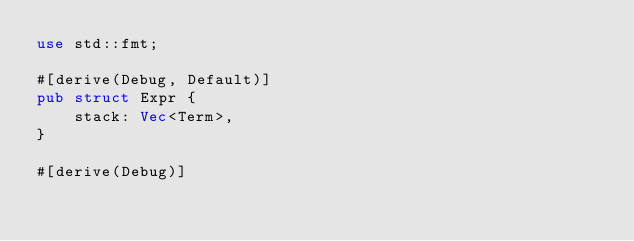Convert code to text. <code><loc_0><loc_0><loc_500><loc_500><_Rust_>use std::fmt;

#[derive(Debug, Default)]
pub struct Expr {
	stack: Vec<Term>,
}

#[derive(Debug)]</code> 